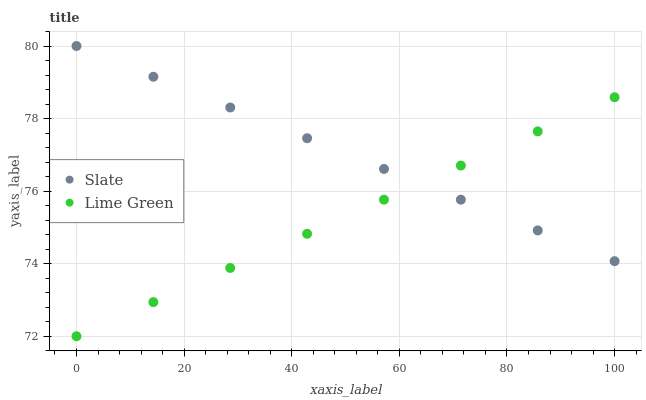Does Lime Green have the minimum area under the curve?
Answer yes or no. Yes. Does Slate have the maximum area under the curve?
Answer yes or no. Yes. Does Lime Green have the maximum area under the curve?
Answer yes or no. No. Is Slate the smoothest?
Answer yes or no. Yes. Is Lime Green the roughest?
Answer yes or no. Yes. Is Lime Green the smoothest?
Answer yes or no. No. Does Lime Green have the lowest value?
Answer yes or no. Yes. Does Slate have the highest value?
Answer yes or no. Yes. Does Lime Green have the highest value?
Answer yes or no. No. Does Lime Green intersect Slate?
Answer yes or no. Yes. Is Lime Green less than Slate?
Answer yes or no. No. Is Lime Green greater than Slate?
Answer yes or no. No. 